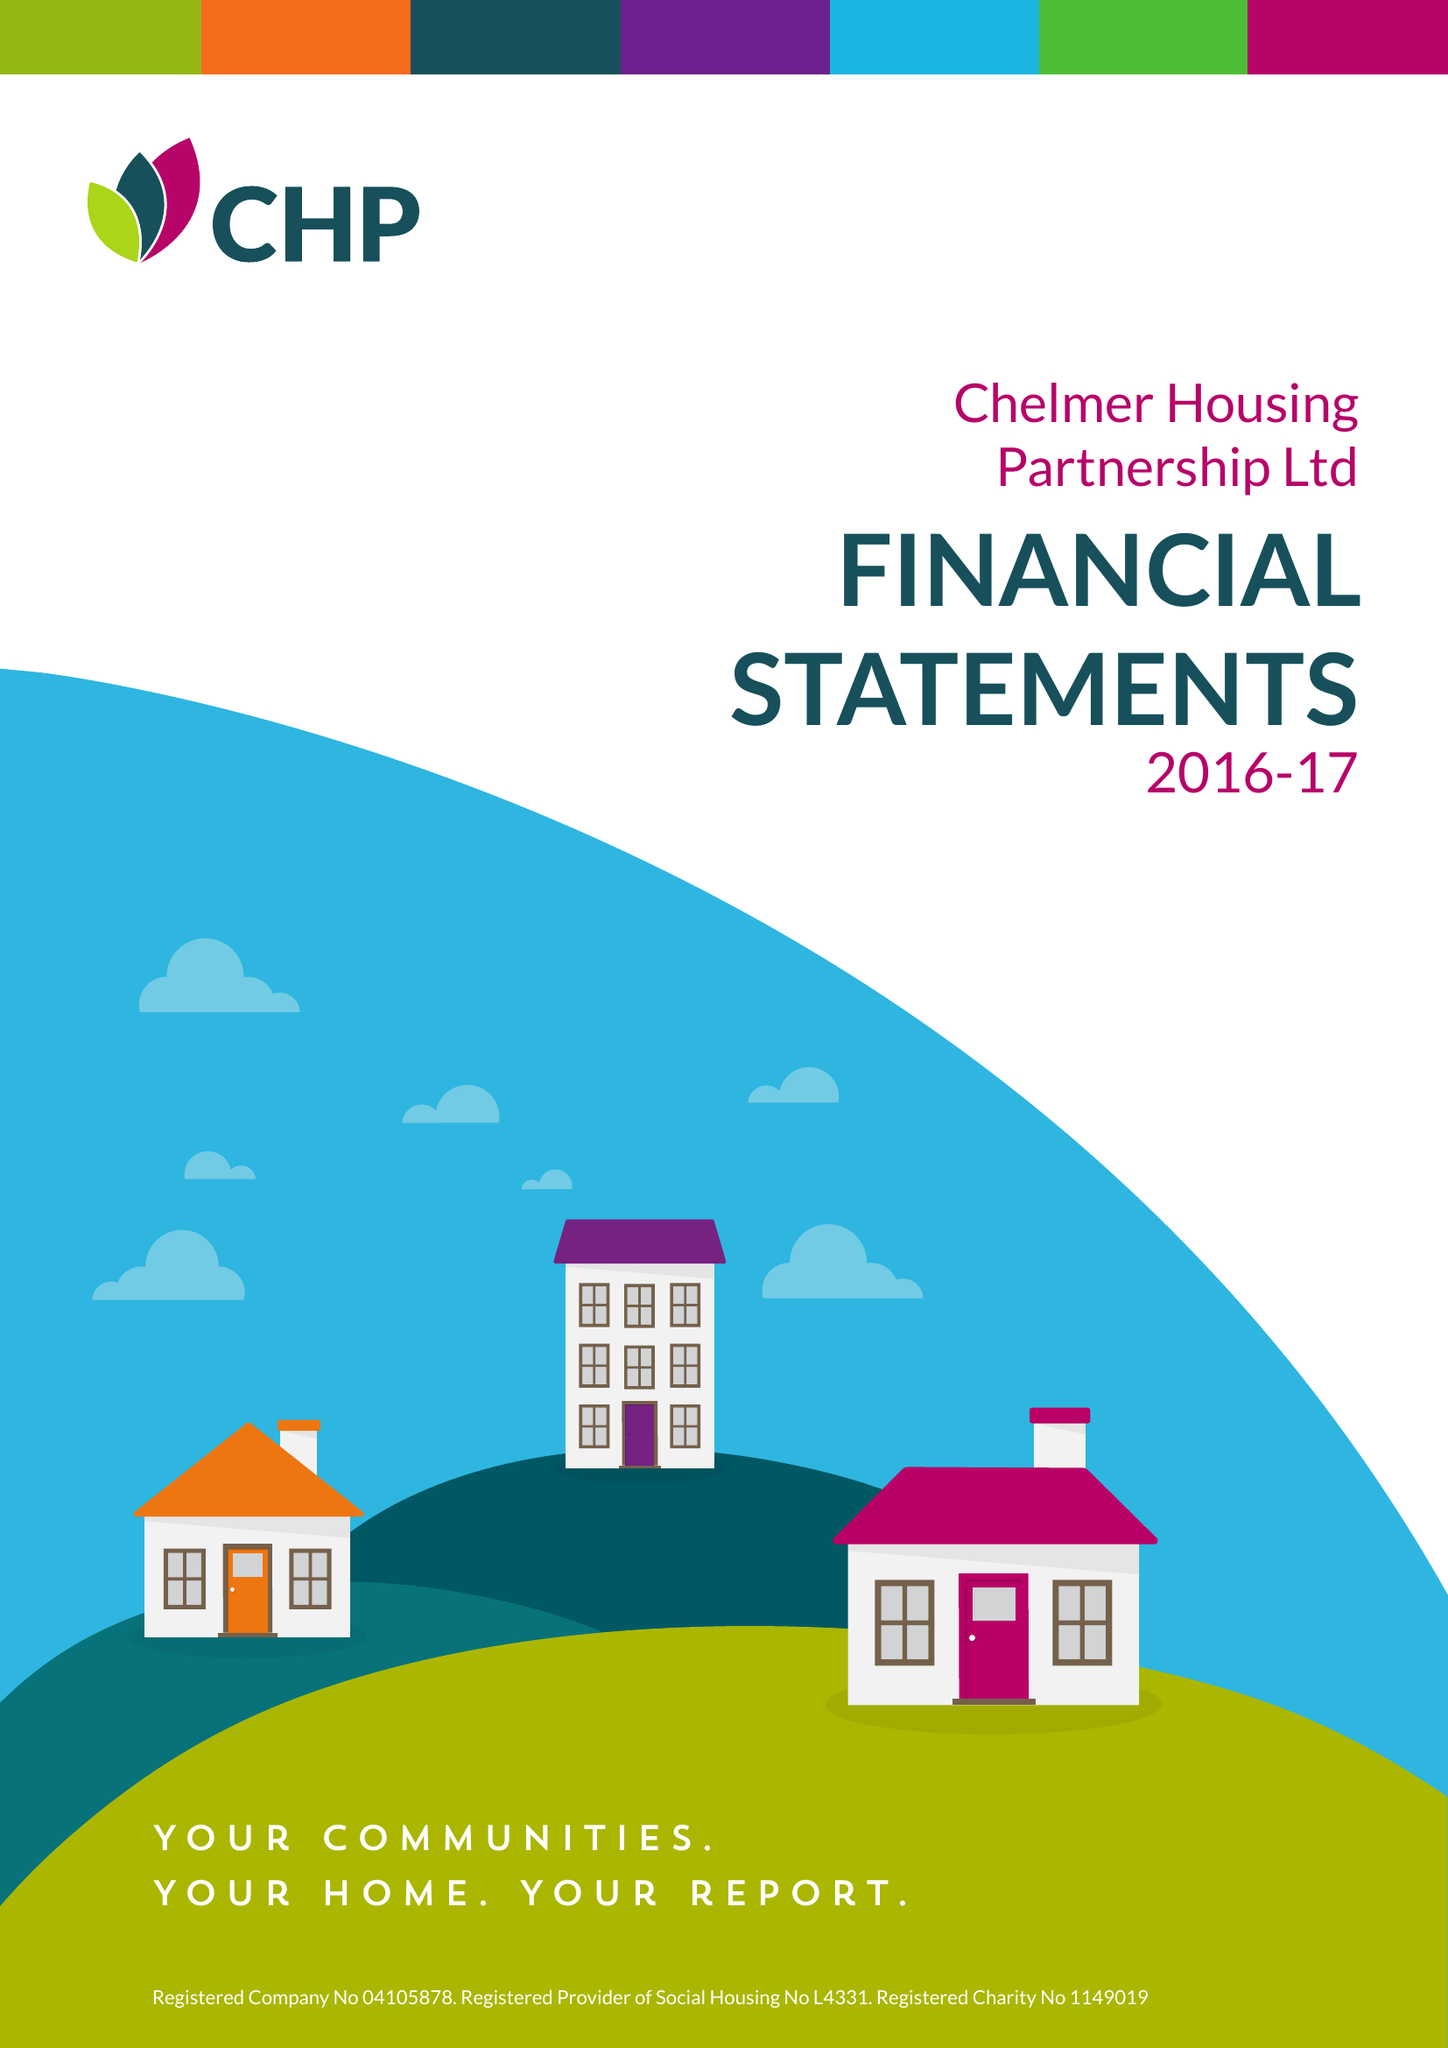What is the value for the charity_name?
Answer the question using a single word or phrase. Chelmer Housing Partnership Ltd. 